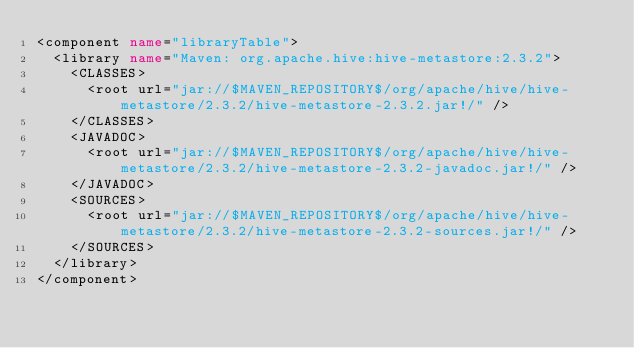Convert code to text. <code><loc_0><loc_0><loc_500><loc_500><_XML_><component name="libraryTable">
  <library name="Maven: org.apache.hive:hive-metastore:2.3.2">
    <CLASSES>
      <root url="jar://$MAVEN_REPOSITORY$/org/apache/hive/hive-metastore/2.3.2/hive-metastore-2.3.2.jar!/" />
    </CLASSES>
    <JAVADOC>
      <root url="jar://$MAVEN_REPOSITORY$/org/apache/hive/hive-metastore/2.3.2/hive-metastore-2.3.2-javadoc.jar!/" />
    </JAVADOC>
    <SOURCES>
      <root url="jar://$MAVEN_REPOSITORY$/org/apache/hive/hive-metastore/2.3.2/hive-metastore-2.3.2-sources.jar!/" />
    </SOURCES>
  </library>
</component></code> 